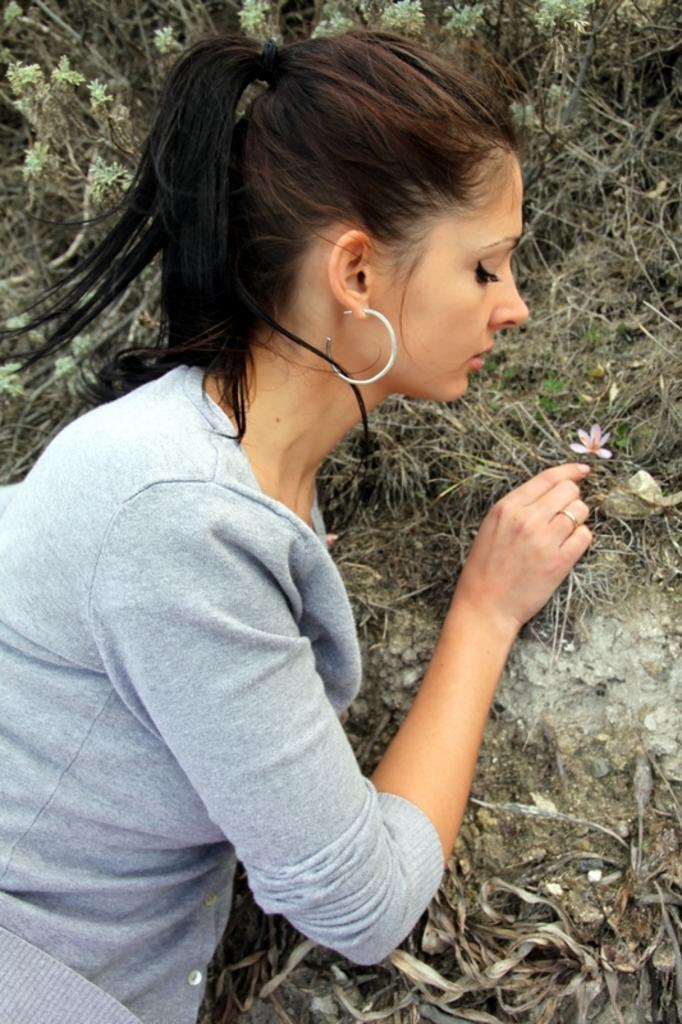Please provide a concise description of this image. Here in this picture we can see a woman standing over a place and in front of her, on the ground we can see grass and plants present and we can also see a flower present on the ground. 